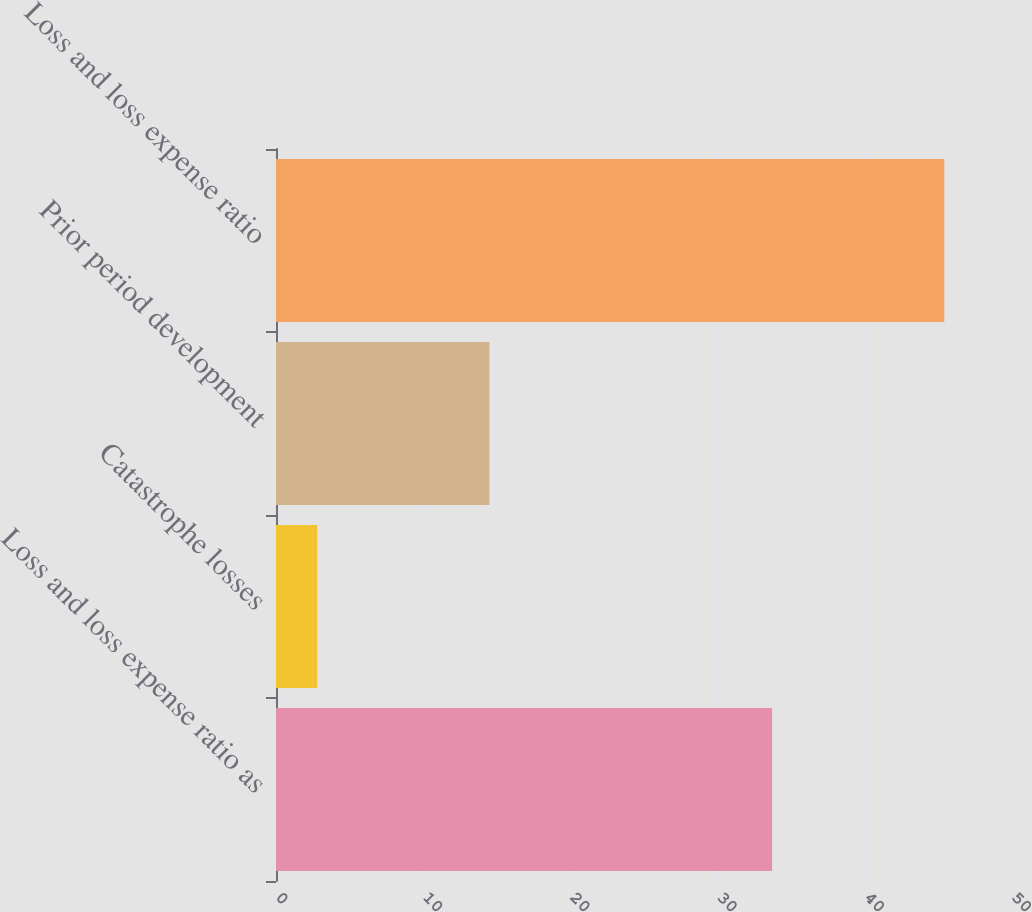Convert chart to OTSL. <chart><loc_0><loc_0><loc_500><loc_500><bar_chart><fcel>Loss and loss expense ratio as<fcel>Catastrophe losses<fcel>Prior period development<fcel>Loss and loss expense ratio<nl><fcel>33.7<fcel>2.8<fcel>14.5<fcel>45.4<nl></chart> 